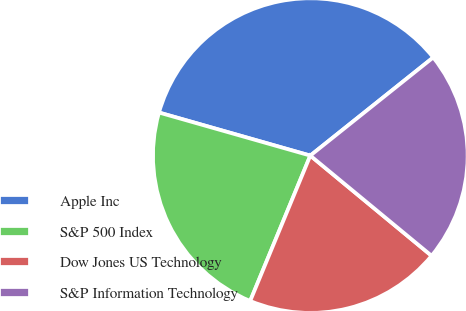Convert chart. <chart><loc_0><loc_0><loc_500><loc_500><pie_chart><fcel>Apple Inc<fcel>S&P 500 Index<fcel>Dow Jones US Technology<fcel>S&P Information Technology<nl><fcel>34.86%<fcel>23.17%<fcel>20.25%<fcel>21.71%<nl></chart> 